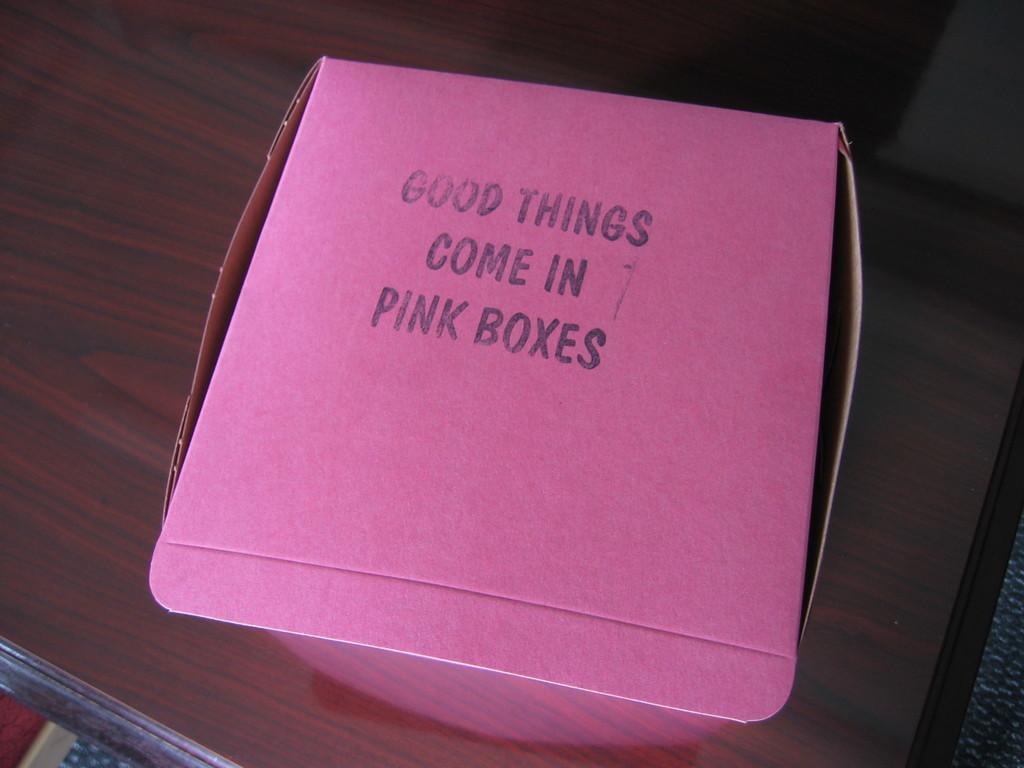What comes in pink boxes?
Offer a very short reply. Good things. What color is the box?
Your response must be concise. Pink. 